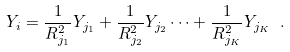Convert formula to latex. <formula><loc_0><loc_0><loc_500><loc_500>Y _ { i } = \frac { 1 } { R _ { j _ { 1 } } ^ { 2 } } Y _ { j _ { 1 } } + \frac { 1 } { R _ { j _ { 2 } } ^ { 2 } } Y _ { j _ { 2 } } \cdots + \frac { 1 } { R _ { j _ { K } } ^ { 2 } } Y _ { j _ { K } } \ .</formula> 